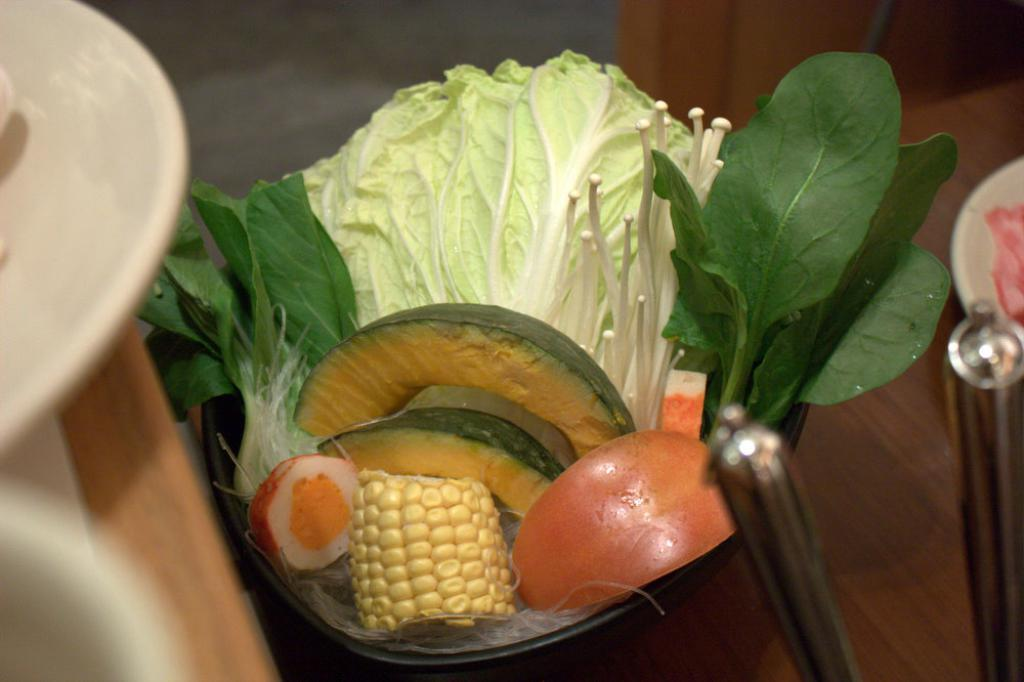What types of items can be seen in the image? There are food items in the image. What is the color of the containers in the image? The containers in the image are white-colored. Can you describe any other objects present in the image? Yes, there are other objects in the image. What is visible beneath the food items and containers? The ground is visible in the image. What arithmetic problem is being solved on the food items in the image? There is no arithmetic problem present on the food items in the image. How many cakes are visible in the image? The provided facts do not specify the type of food items in the image, so it is impossible to determine if there are any cakes present. 